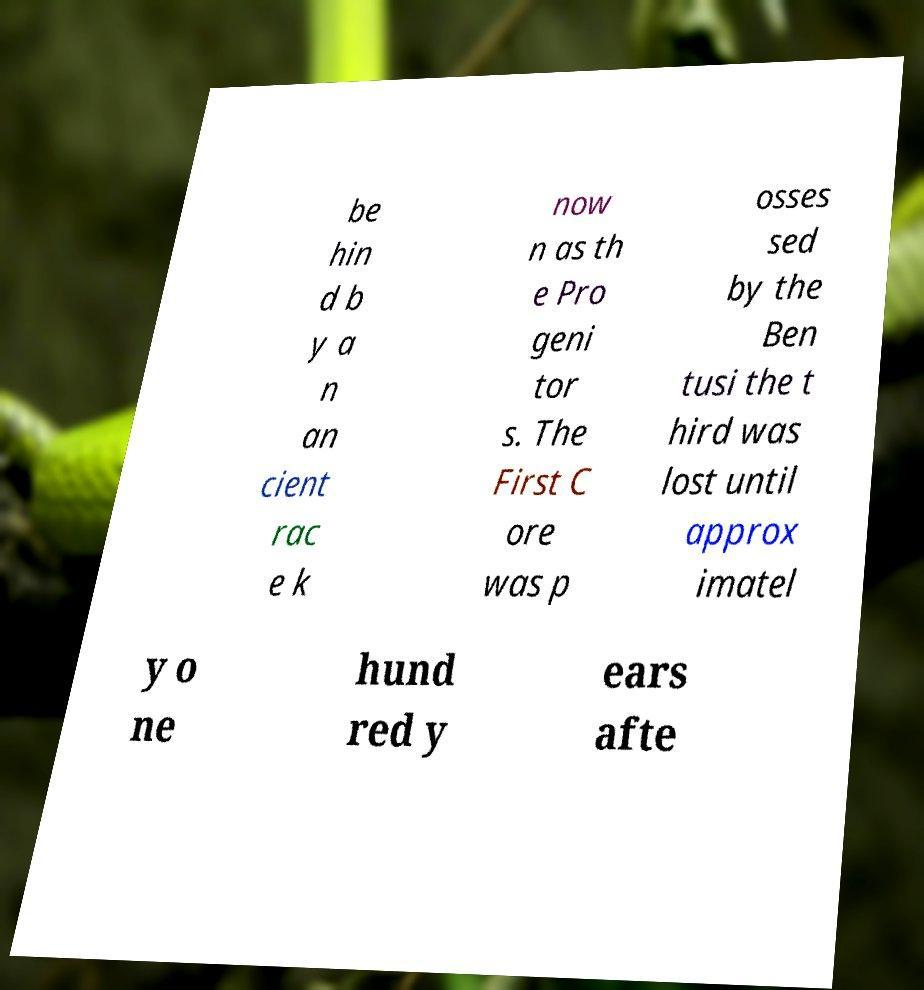What messages or text are displayed in this image? I need them in a readable, typed format. be hin d b y a n an cient rac e k now n as th e Pro geni tor s. The First C ore was p osses sed by the Ben tusi the t hird was lost until approx imatel y o ne hund red y ears afte 